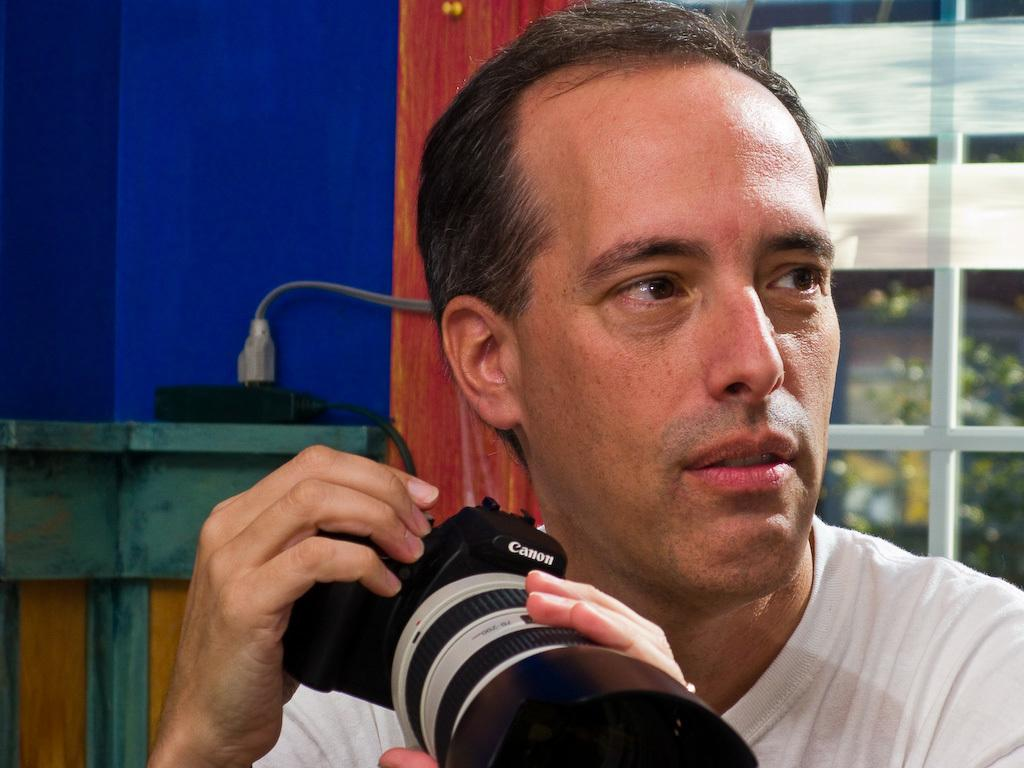What is the person in the image holding? The person is holding a camera. What can be seen in the background of the image? There is a window and trees visible in the background. What type of argument is the person having with the trees in the background? There is no argument present in the image; the person is simply holding a camera and there are trees visible in the background. 